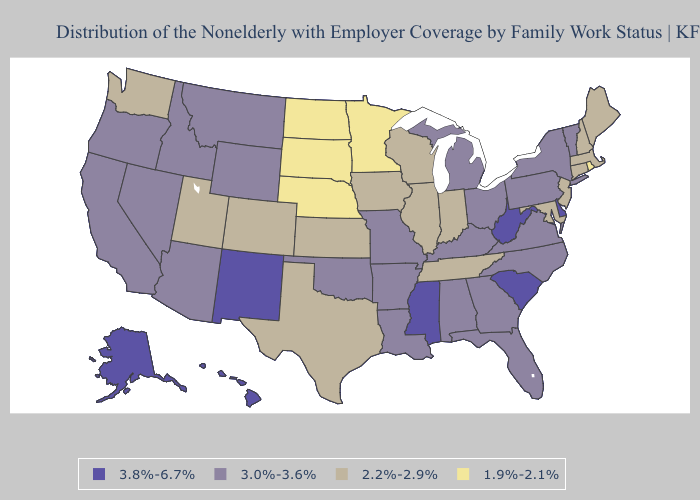What is the value of Louisiana?
Quick response, please. 3.0%-3.6%. What is the lowest value in states that border Nevada?
Answer briefly. 2.2%-2.9%. What is the highest value in the USA?
Quick response, please. 3.8%-6.7%. What is the highest value in the USA?
Quick response, please. 3.8%-6.7%. Does New Hampshire have a higher value than Kentucky?
Give a very brief answer. No. Name the states that have a value in the range 3.8%-6.7%?
Answer briefly. Alaska, Delaware, Hawaii, Mississippi, New Mexico, South Carolina, West Virginia. Does Wyoming have the same value as Massachusetts?
Keep it brief. No. What is the value of North Dakota?
Keep it brief. 1.9%-2.1%. What is the value of New Mexico?
Give a very brief answer. 3.8%-6.7%. Among the states that border Virginia , does Tennessee have the lowest value?
Give a very brief answer. Yes. What is the value of Mississippi?
Write a very short answer. 3.8%-6.7%. Does Hawaii have the highest value in the USA?
Concise answer only. Yes. Which states have the lowest value in the USA?
Concise answer only. Minnesota, Nebraska, North Dakota, Rhode Island, South Dakota. What is the highest value in states that border Idaho?
Short answer required. 3.0%-3.6%. 